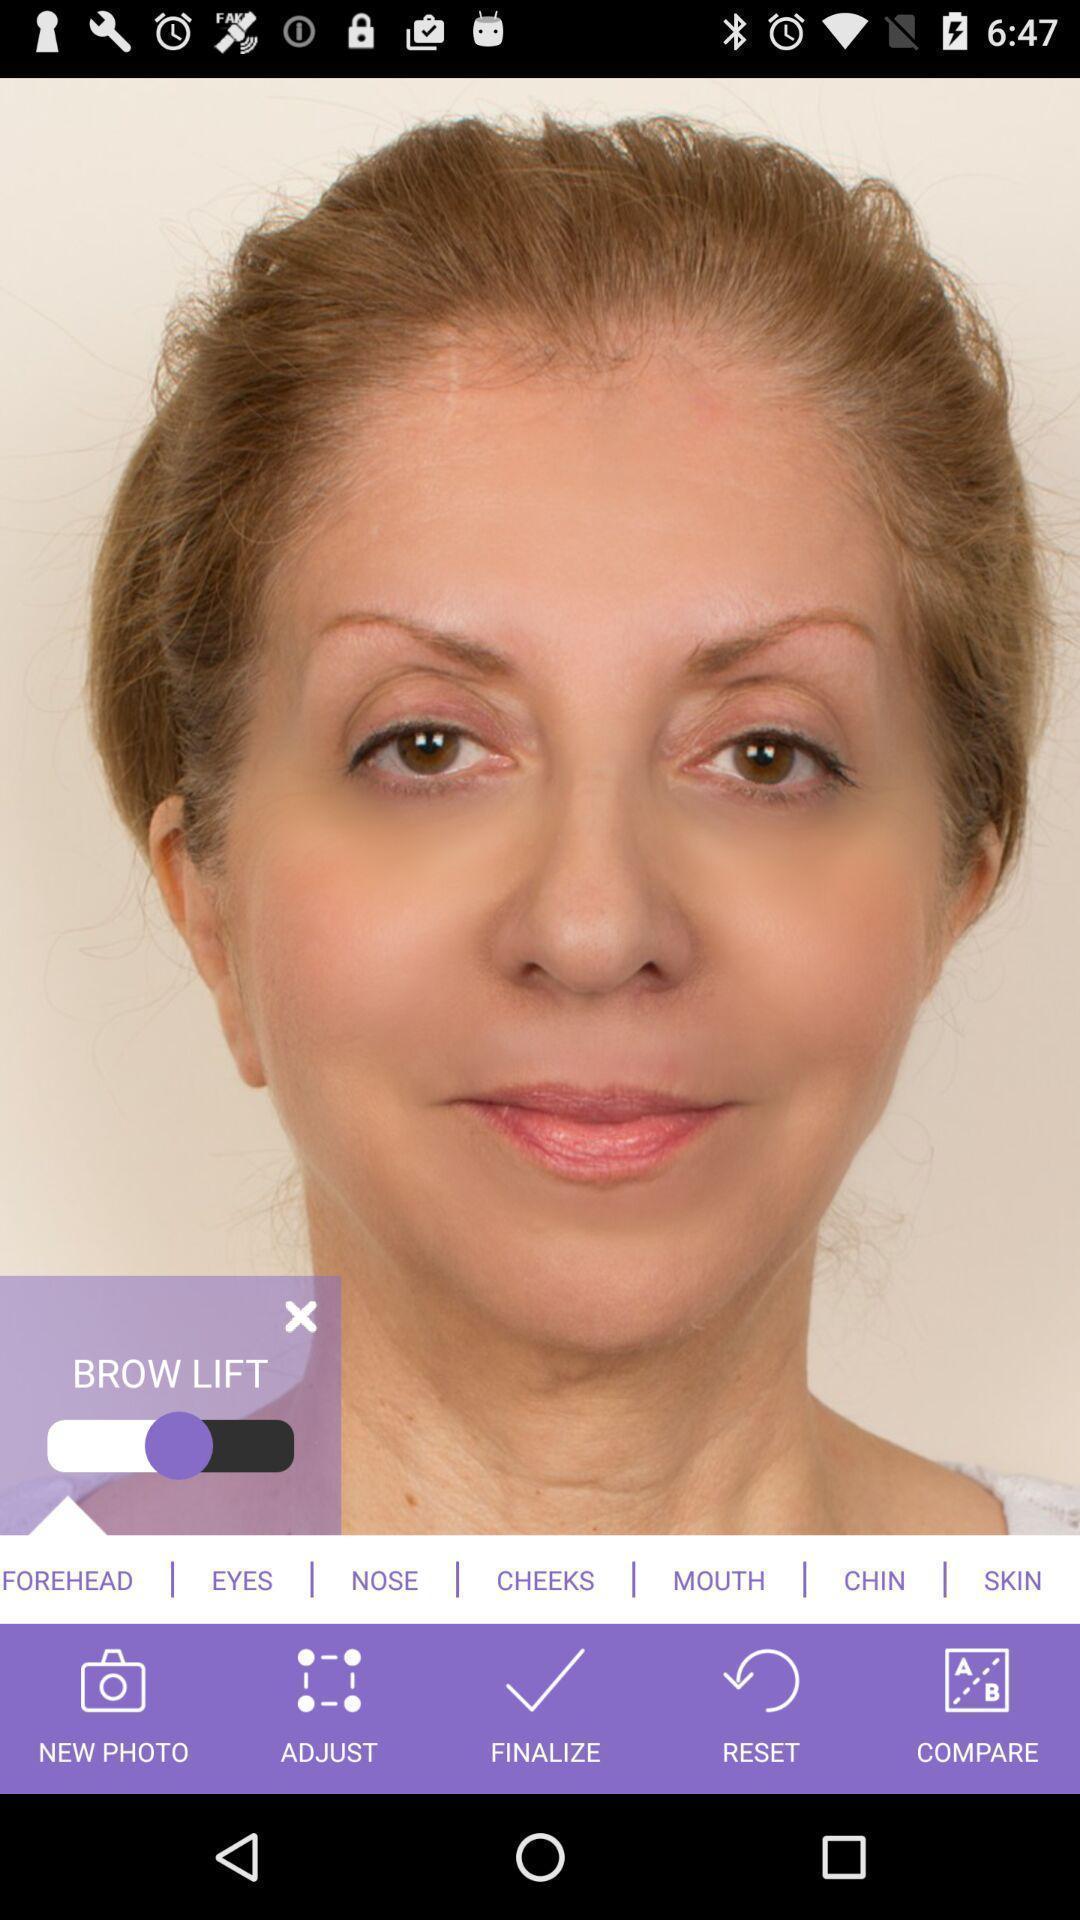Tell me what you see in this picture. Photograph displayed with edit options. 